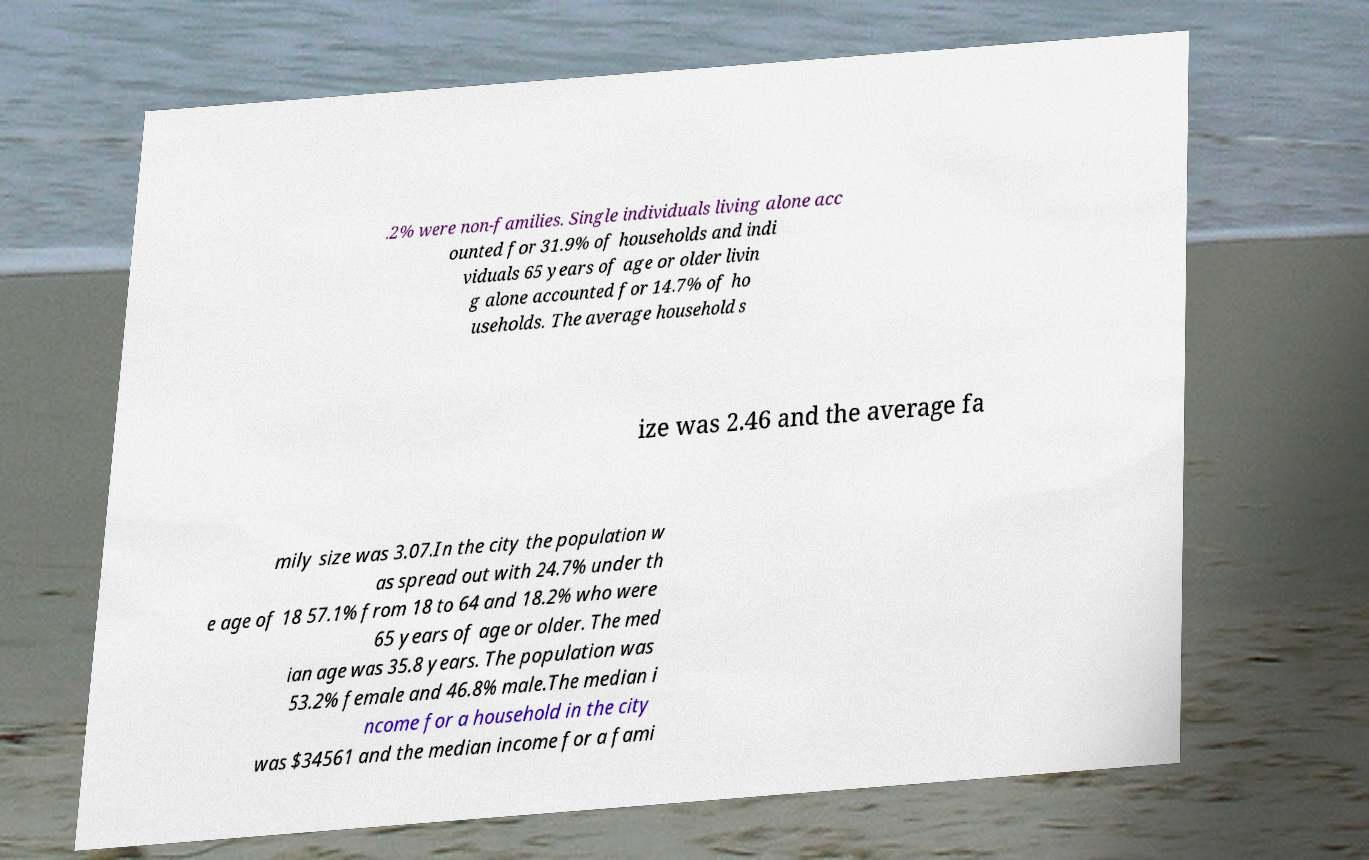For documentation purposes, I need the text within this image transcribed. Could you provide that? .2% were non-families. Single individuals living alone acc ounted for 31.9% of households and indi viduals 65 years of age or older livin g alone accounted for 14.7% of ho useholds. The average household s ize was 2.46 and the average fa mily size was 3.07.In the city the population w as spread out with 24.7% under th e age of 18 57.1% from 18 to 64 and 18.2% who were 65 years of age or older. The med ian age was 35.8 years. The population was 53.2% female and 46.8% male.The median i ncome for a household in the city was $34561 and the median income for a fami 